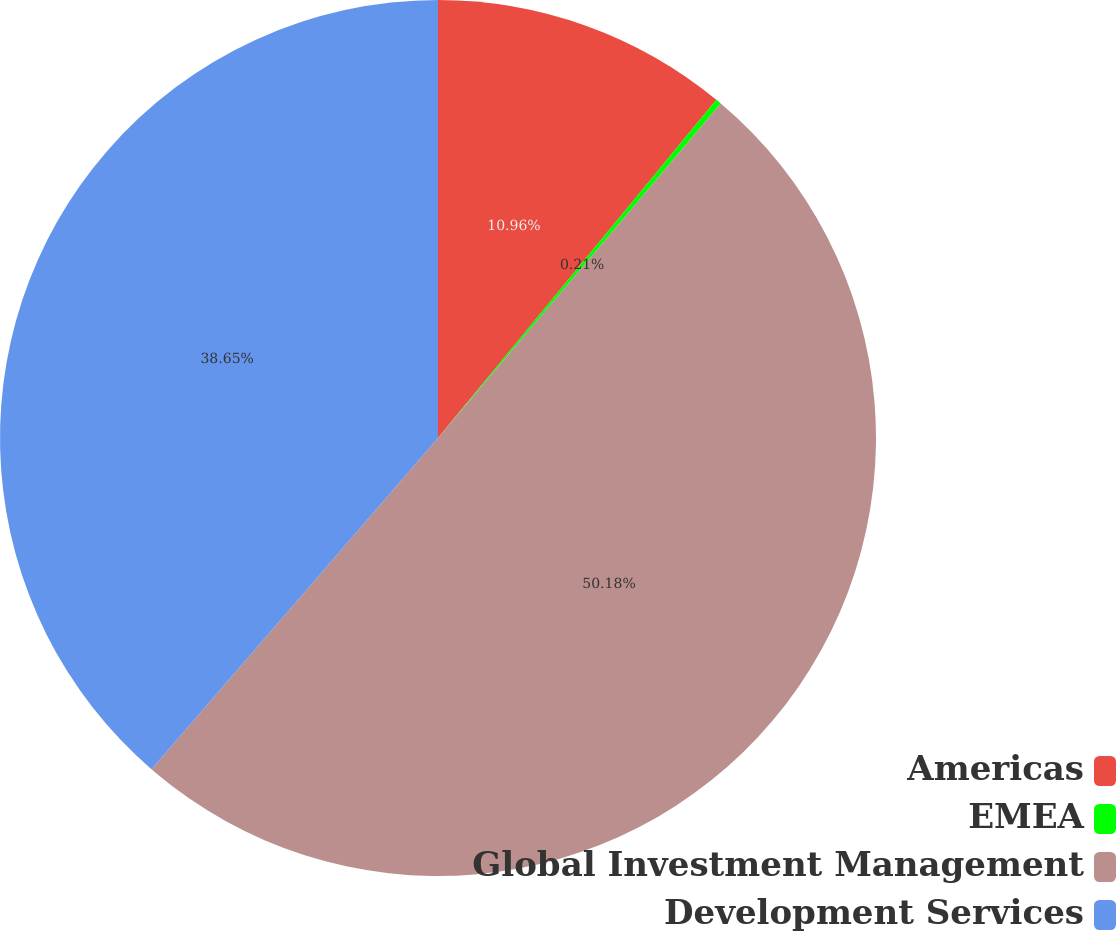Convert chart. <chart><loc_0><loc_0><loc_500><loc_500><pie_chart><fcel>Americas<fcel>EMEA<fcel>Global Investment Management<fcel>Development Services<nl><fcel>10.96%<fcel>0.21%<fcel>50.18%<fcel>38.65%<nl></chart> 